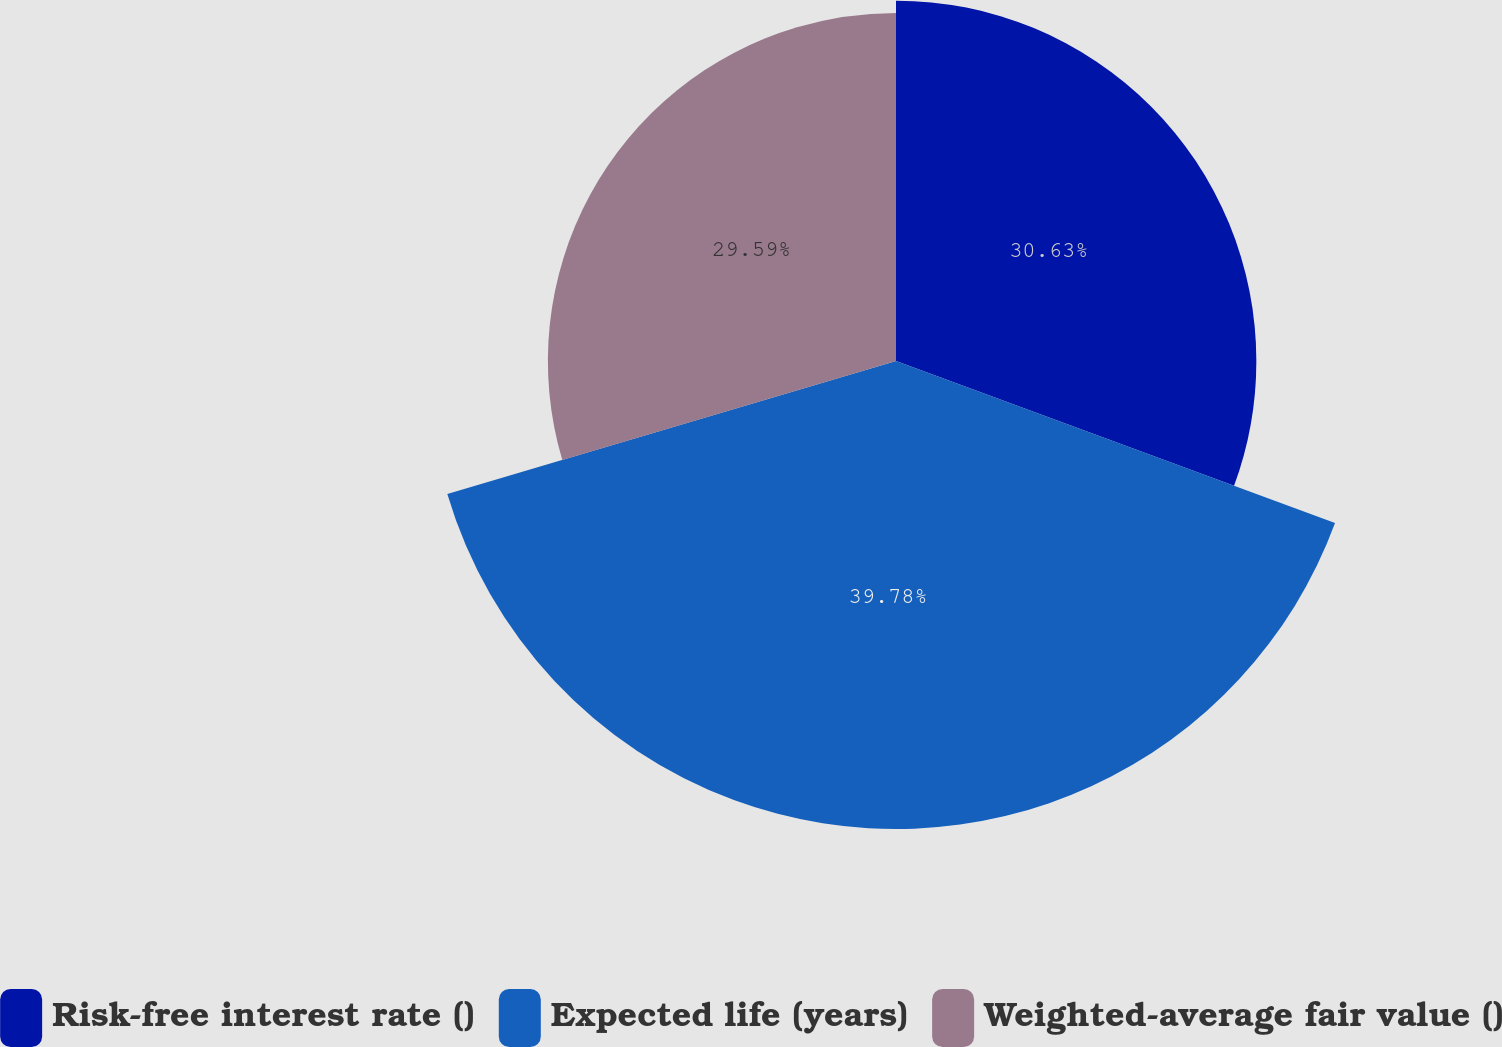Convert chart. <chart><loc_0><loc_0><loc_500><loc_500><pie_chart><fcel>Risk-free interest rate ()<fcel>Expected life (years)<fcel>Weighted-average fair value ()<nl><fcel>30.63%<fcel>39.78%<fcel>29.59%<nl></chart> 